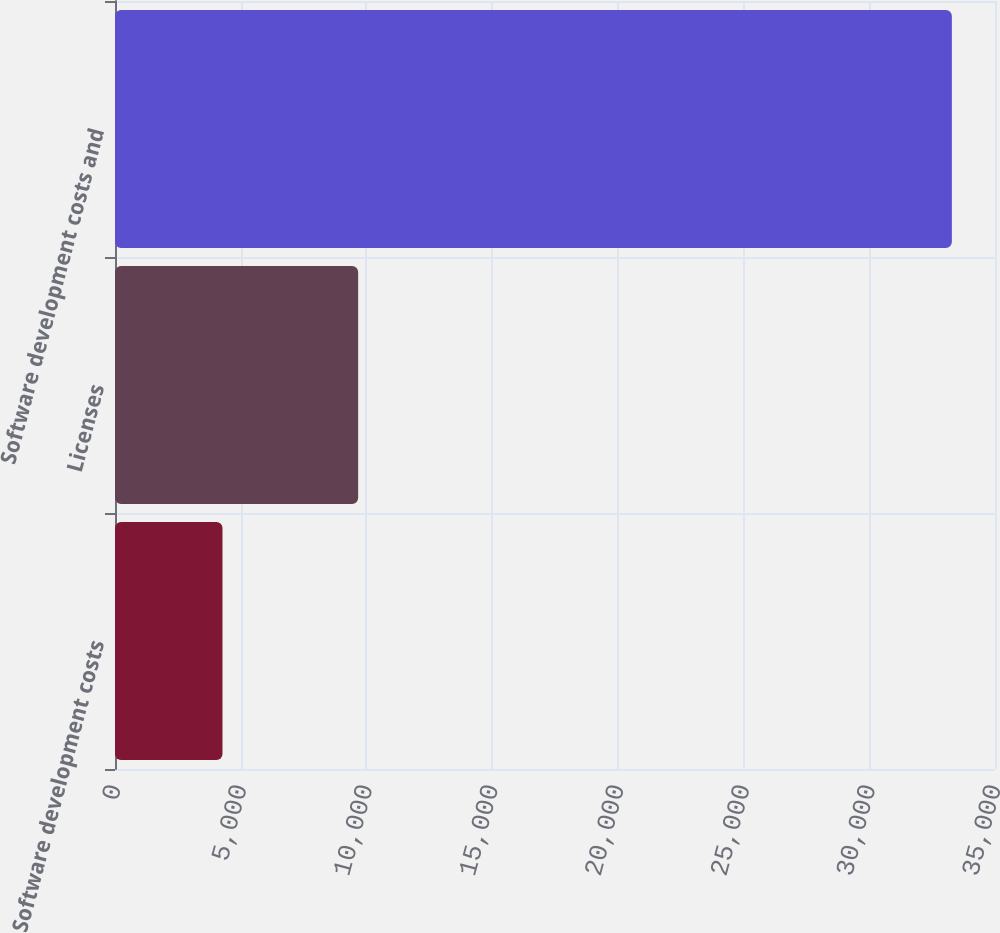Convert chart. <chart><loc_0><loc_0><loc_500><loc_500><bar_chart><fcel>Software development costs<fcel>Licenses<fcel>Software development costs and<nl><fcel>4275<fcel>9671<fcel>33284<nl></chart> 